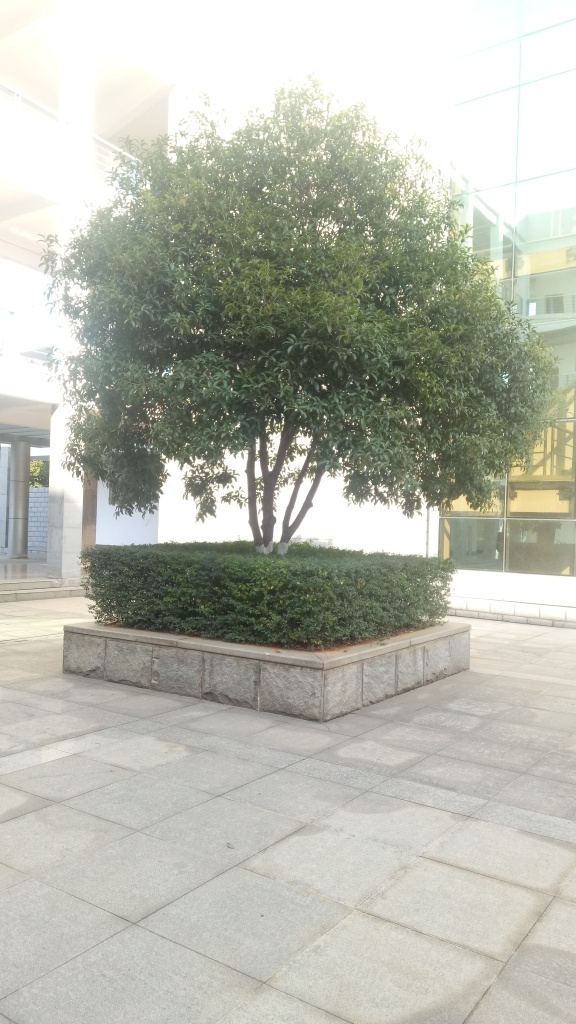What time of day does this photo seem to be taken? Based on the lighting and the length of the shadows cast by the tree, this photo appears to be taken in the late afternoon when the sun is not at its peak brightness. 